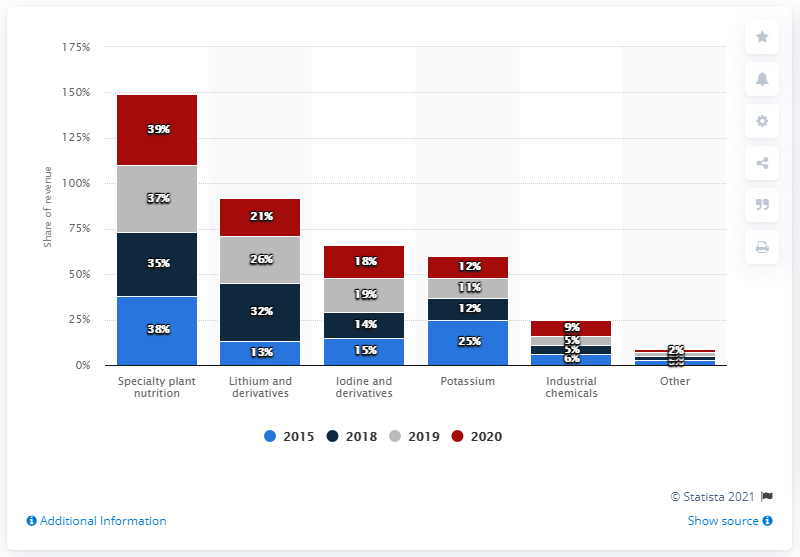Identify some key points in this picture. SQM, a leading business segment in the lithium industry, is recognized as the world's largest lithium producer, specializing in lithium and its derivatives. 